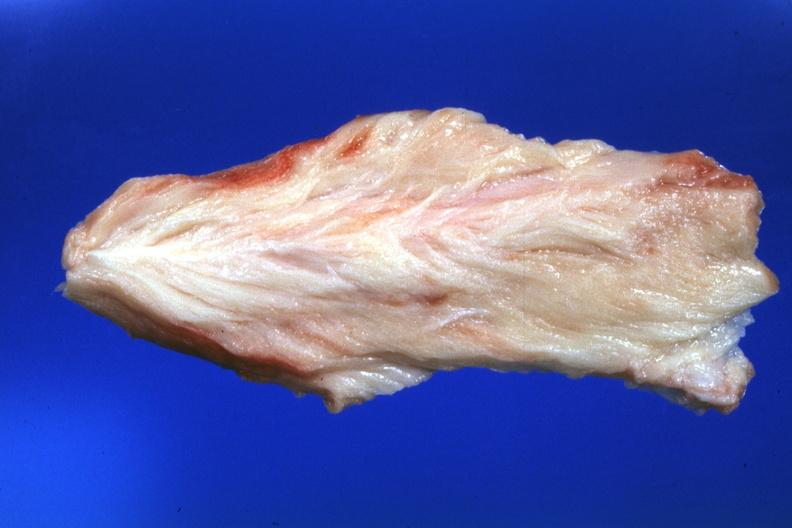what is present?
Answer the question using a single word or phrase. Soft tissue 